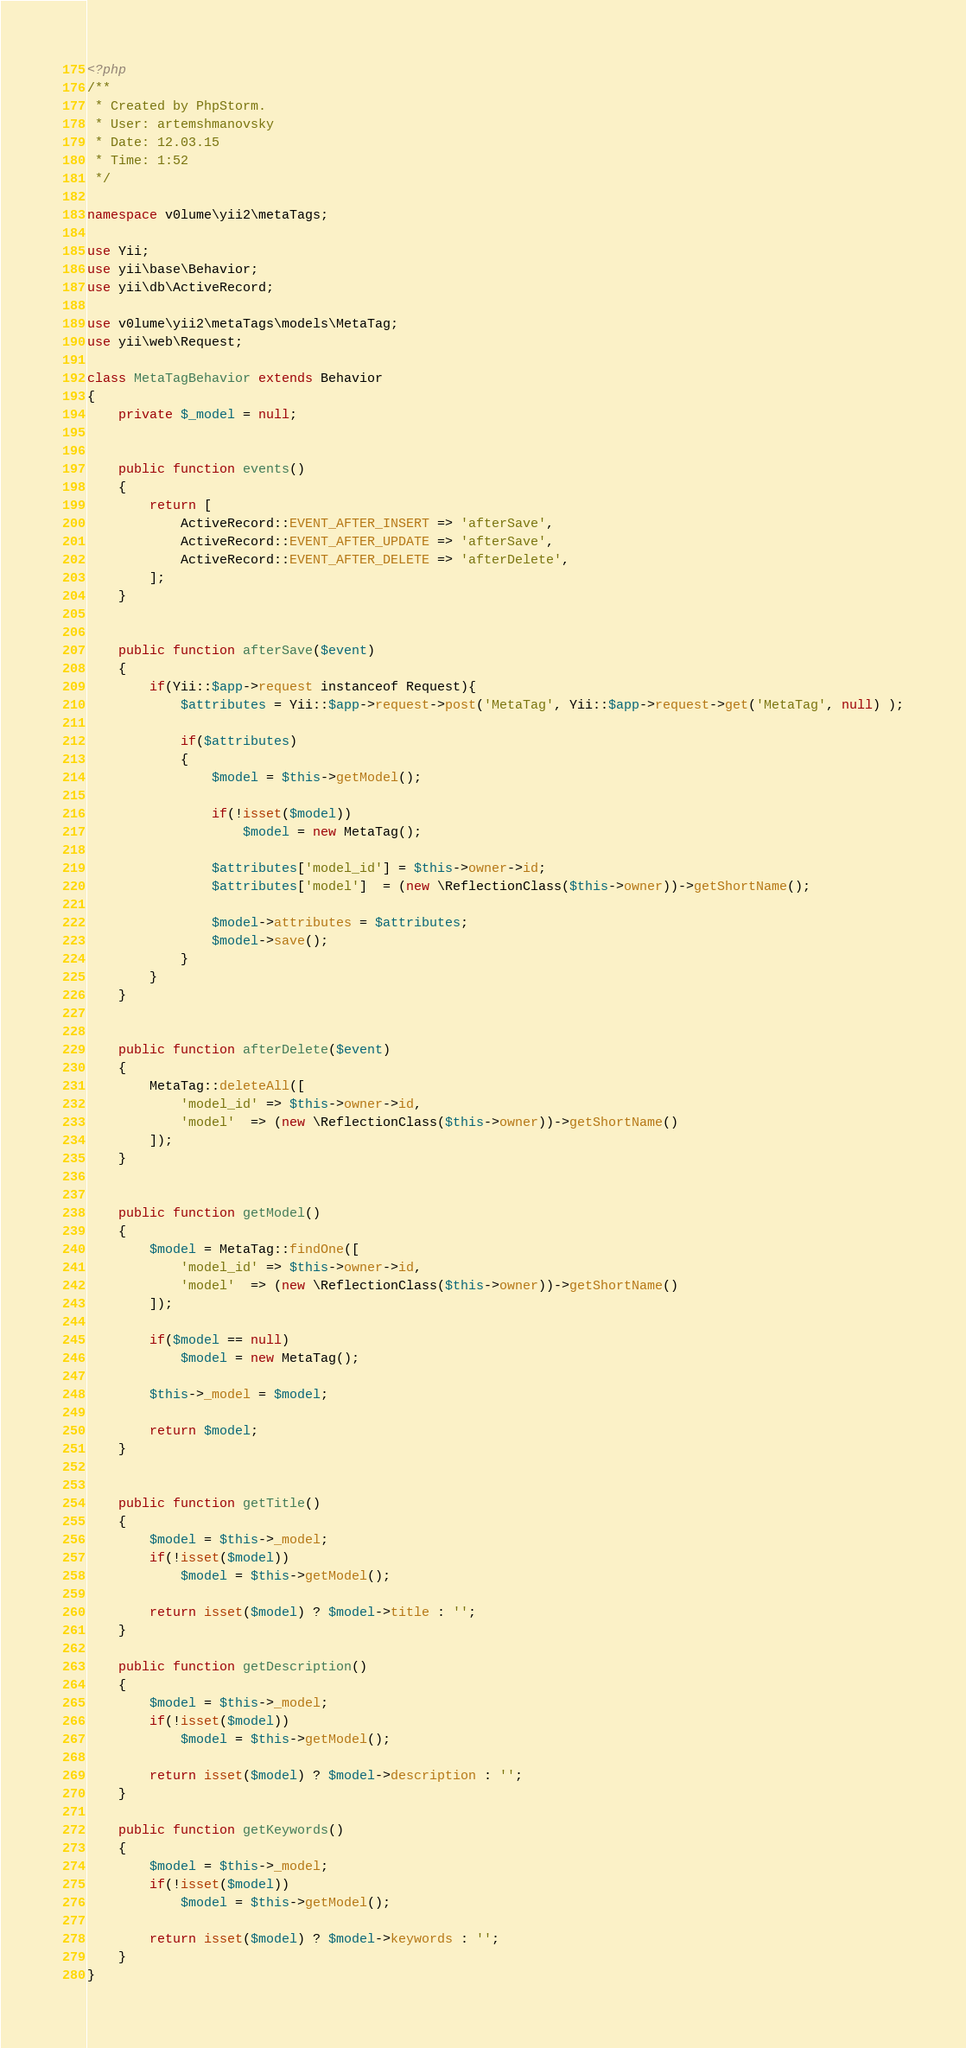Convert code to text. <code><loc_0><loc_0><loc_500><loc_500><_PHP_><?php
/**
 * Created by PhpStorm.
 * User: artemshmanovsky
 * Date: 12.03.15
 * Time: 1:52
 */

namespace v0lume\yii2\metaTags;

use Yii;
use yii\base\Behavior;
use yii\db\ActiveRecord;

use v0lume\yii2\metaTags\models\MetaTag;
use yii\web\Request;

class MetaTagBehavior extends Behavior
{
    private $_model = null;


    public function events()
    {
        return [
            ActiveRecord::EVENT_AFTER_INSERT => 'afterSave',
            ActiveRecord::EVENT_AFTER_UPDATE => 'afterSave',
            ActiveRecord::EVENT_AFTER_DELETE => 'afterDelete',
        ];
    }


    public function afterSave($event)
    {
        if(Yii::$app->request instanceof Request){
            $attributes = Yii::$app->request->post('MetaTag', Yii::$app->request->get('MetaTag', null) );

            if($attributes)
            {
                $model = $this->getModel();

                if(!isset($model))
                    $model = new MetaTag();

                $attributes['model_id'] = $this->owner->id;
                $attributes['model']  = (new \ReflectionClass($this->owner))->getShortName();

                $model->attributes = $attributes;
                $model->save();
            }
        }
    }


    public function afterDelete($event)
    {
        MetaTag::deleteAll([
            'model_id' => $this->owner->id,
            'model'  => (new \ReflectionClass($this->owner))->getShortName()
        ]);
    }


    public function getModel()
    {
        $model = MetaTag::findOne([
            'model_id' => $this->owner->id,
            'model'  => (new \ReflectionClass($this->owner))->getShortName()
        ]);

        if($model == null)
            $model = new MetaTag();

        $this->_model = $model;

        return $model;
    }


    public function getTitle()
    {
        $model = $this->_model;
        if(!isset($model))
            $model = $this->getModel();

        return isset($model) ? $model->title : '';
    }

    public function getDescription()
    {
        $model = $this->_model;
        if(!isset($model))
            $model = $this->getModel();

        return isset($model) ? $model->description : '';
    }

    public function getKeywords()
    {
        $model = $this->_model;
        if(!isset($model))
            $model = $this->getModel();

        return isset($model) ? $model->keywords : '';
    }
}
</code> 